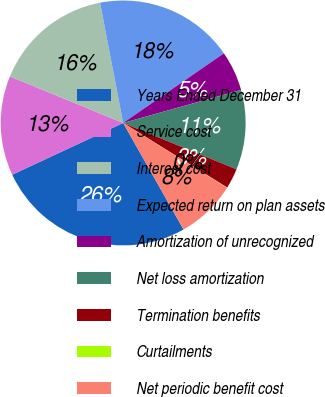Convert chart. <chart><loc_0><loc_0><loc_500><loc_500><pie_chart><fcel>Years Ended December 31<fcel>Service cost<fcel>Interest cost<fcel>Expected return on plan assets<fcel>Amortization of unrecognized<fcel>Net loss amortization<fcel>Termination benefits<fcel>Curtailments<fcel>Net periodic benefit cost<nl><fcel>26.26%<fcel>13.15%<fcel>15.77%<fcel>18.4%<fcel>5.28%<fcel>10.53%<fcel>2.66%<fcel>0.04%<fcel>7.91%<nl></chart> 